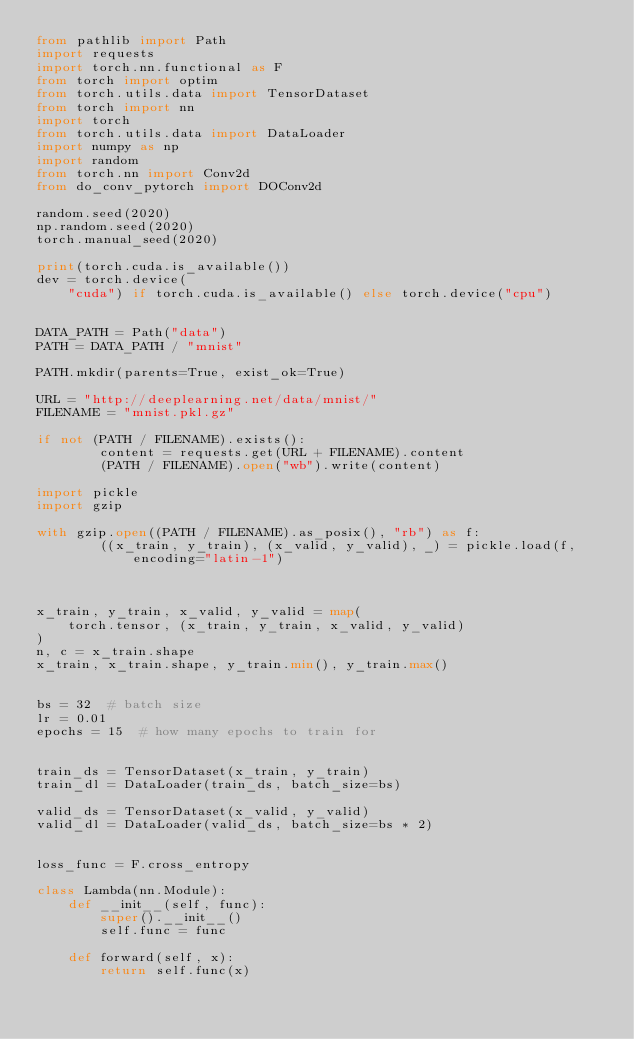Convert code to text. <code><loc_0><loc_0><loc_500><loc_500><_Python_>from pathlib import Path
import requests
import torch.nn.functional as F
from torch import optim
from torch.utils.data import TensorDataset
from torch import nn
import torch
from torch.utils.data import DataLoader
import numpy as np
import random
from torch.nn import Conv2d
from do_conv_pytorch import DOConv2d

random.seed(2020)
np.random.seed(2020)
torch.manual_seed(2020)

print(torch.cuda.is_available())
dev = torch.device(
    "cuda") if torch.cuda.is_available() else torch.device("cpu")


DATA_PATH = Path("data")
PATH = DATA_PATH / "mnist"

PATH.mkdir(parents=True, exist_ok=True)

URL = "http://deeplearning.net/data/mnist/"
FILENAME = "mnist.pkl.gz"

if not (PATH / FILENAME).exists():
        content = requests.get(URL + FILENAME).content
        (PATH / FILENAME).open("wb").write(content)

import pickle
import gzip

with gzip.open((PATH / FILENAME).as_posix(), "rb") as f:
        ((x_train, y_train), (x_valid, y_valid), _) = pickle.load(f, encoding="latin-1")



x_train, y_train, x_valid, y_valid = map(
    torch.tensor, (x_train, y_train, x_valid, y_valid)
)
n, c = x_train.shape
x_train, x_train.shape, y_train.min(), y_train.max()


bs = 32  # batch size
lr = 0.01
epochs = 15  # how many epochs to train for


train_ds = TensorDataset(x_train, y_train)
train_dl = DataLoader(train_ds, batch_size=bs)

valid_ds = TensorDataset(x_valid, y_valid)
valid_dl = DataLoader(valid_ds, batch_size=bs * 2)


loss_func = F.cross_entropy

class Lambda(nn.Module):
    def __init__(self, func):
        super().__init__()
        self.func = func

    def forward(self, x):
        return self.func(x)

</code> 